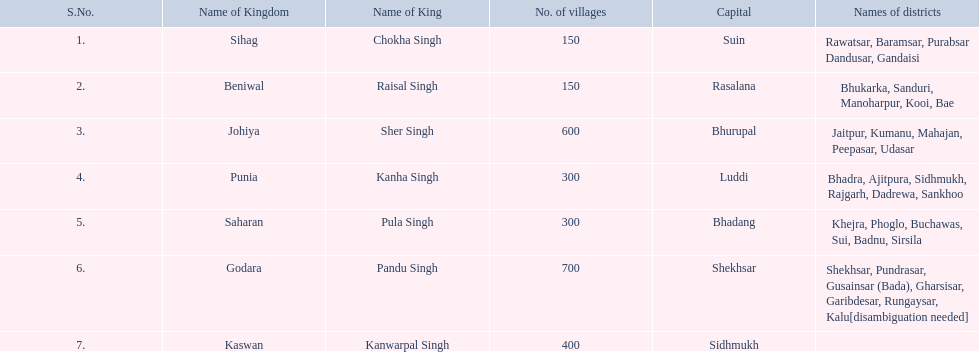What is the total number of kingdoms mentioned? 7. 